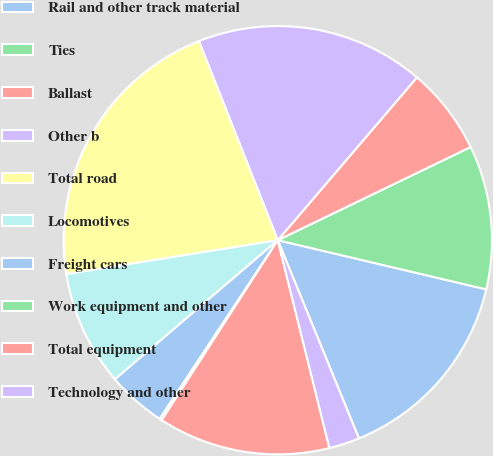Convert chart to OTSL. <chart><loc_0><loc_0><loc_500><loc_500><pie_chart><fcel>Rail and other track material<fcel>Ties<fcel>Ballast<fcel>Other b<fcel>Total road<fcel>Locomotives<fcel>Freight cars<fcel>Work equipment and other<fcel>Total equipment<fcel>Technology and other<nl><fcel>15.13%<fcel>10.85%<fcel>6.58%<fcel>17.26%<fcel>21.53%<fcel>8.72%<fcel>4.45%<fcel>0.18%<fcel>12.99%<fcel>2.31%<nl></chart> 